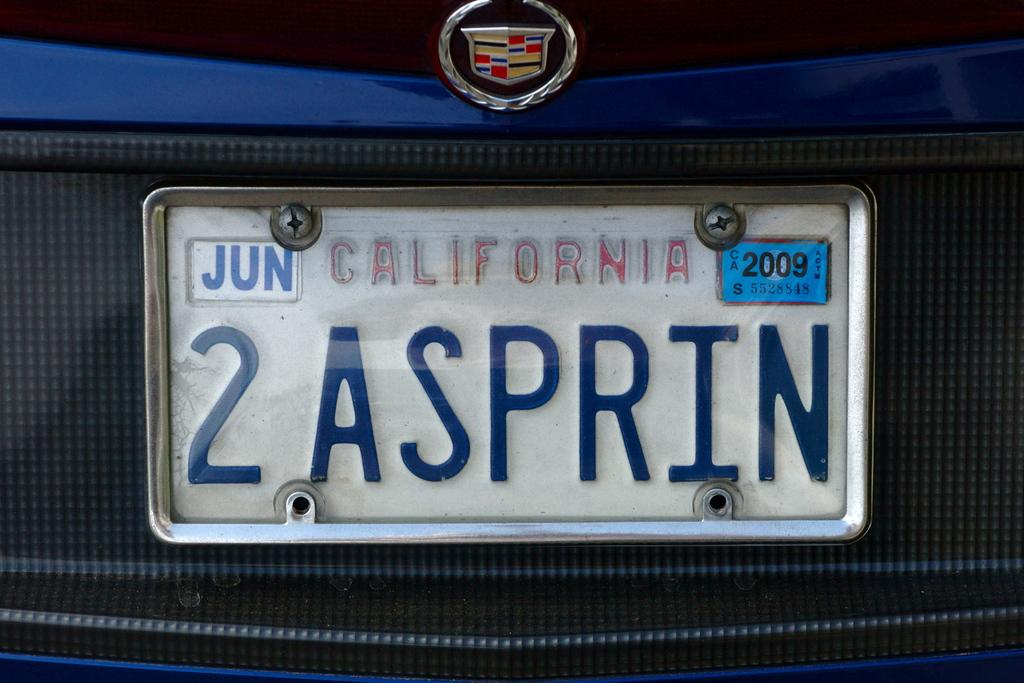What can be seen on the registration plate in the image? There is a registration plate with numbers and words in the image. What is attached to the vehicle in the image? There is a logo attached to the vehicle in the image. Can you tell me how many quarters are visible on the road in the image? There is no road or quarters present in the image; it only features a registration plate and a logo attached to a vehicle. 